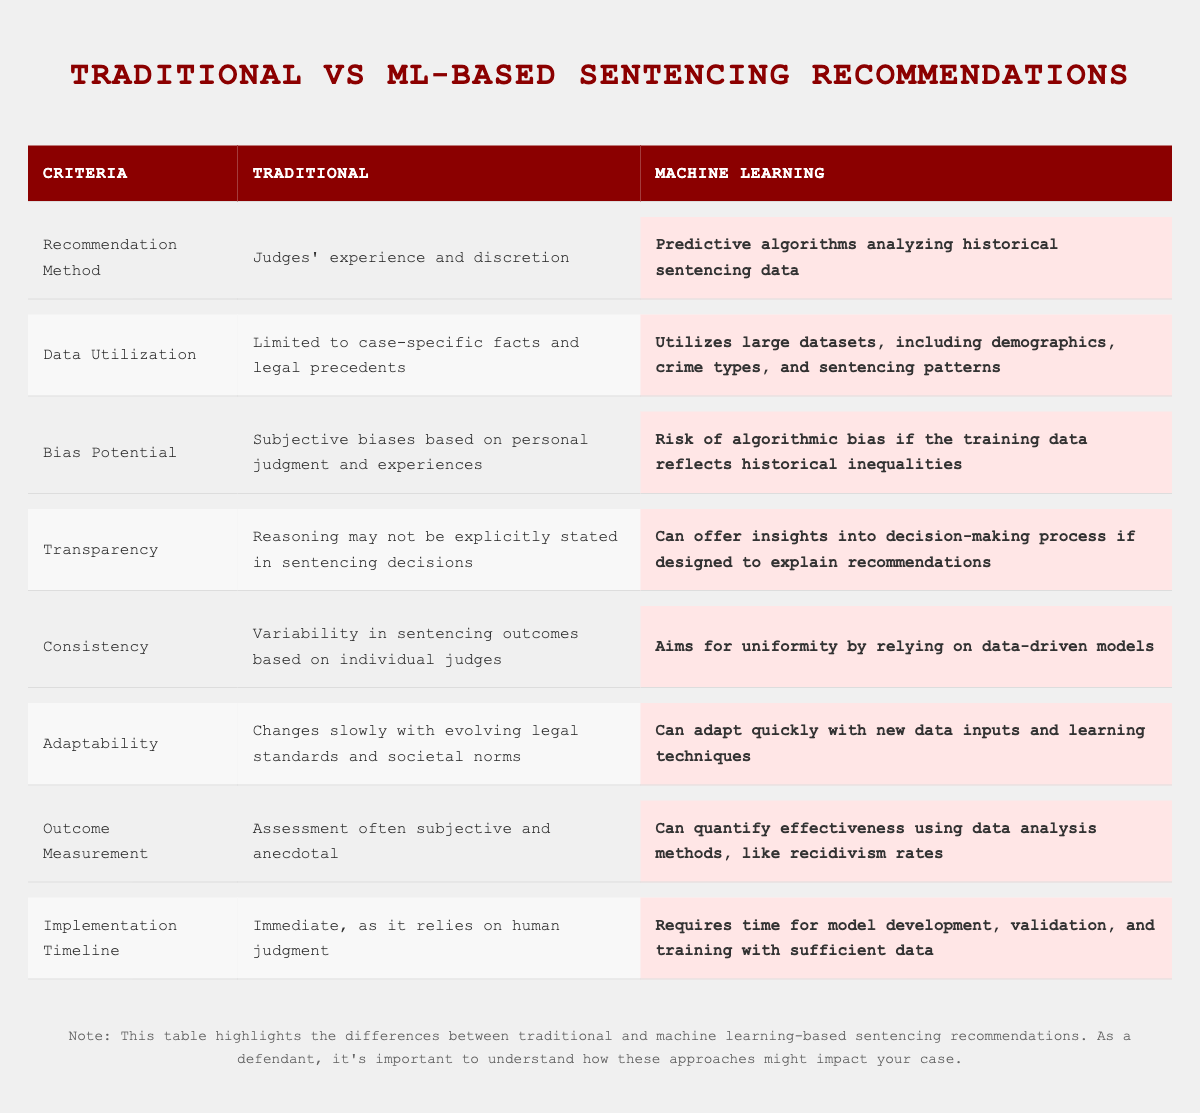What is the recommendation method in traditional sentencing? The table states that the recommendation method in traditional sentencing is based on judges' experience and discretion.
Answer: Judges' experience and discretion What type of data does machine learning utilize for sentencing recommendations? According to the table, machine learning utilizes large datasets, including demographics, crime types, and sentencing patterns.
Answer: Large datasets including demographics, crime types, and sentencing patterns Is there a risk of bias in machine learning sentencing recommendations? The table indicates that there is a risk of algorithmic bias if the training data reflects historical inequalities.
Answer: Yes, there is a risk of algorithmic bias What is one way that machine learning aims to improve consistency in sentencing outcomes? The table notes that machine learning aims for uniformity by relying on data-driven models, which can reduce variability in outcomes.
Answer: By relying on data-driven models for uniformity How quickly can machine learning adapt to new data compared to traditional methods? The table shows that machine learning can adapt quickly with new data inputs and learning techniques, while traditional methods change slowly.
Answer: Machine learning can adapt quickly What are the main factors that lead to variability in traditional sentencing? The table states that variability in traditional sentencing outcomes is based on individual judges' discretion and experience.
Answer: Individual judges' discretion and experience Can machine learning provide transparency in decision-making processes? The table suggests that if designed correctly, machine learning can offer insights into the decision-making process for sentencing recommendations.
Answer: Yes, it can offer insights if designed to explain How does the outcome measurement in machine learning differ from traditional methods? Machine learning can quantify effectiveness through data analysis methods, while traditional assessment is often subjective and anecdotal.
Answer: Machine learning quantifies effectiveness; traditional methods are subjective What is the implementation timeline difference between traditional and machine learning methods? Traditional sentencing methods can be implemented immediately as they rely on human judgment, while machine learning requires time for model development and training.
Answer: Traditional methods are immediate; ML methods take time What potential issue arises from the use of subjective biases in traditional sentencing? The table points out that subjective biases can affect the fairness and consistency of sentencing decisions in traditional methods.
Answer: It can affect fairness and consistency How does the role of data in sentencing impact the adaptability of machine learning methods compared to traditional ones? According to the table, machine learning can adapt quickly with new data inputs, while traditional methods change slowly due to evolving legal standards.
Answer: Machine learning adapts quickly; traditional changes slowly 